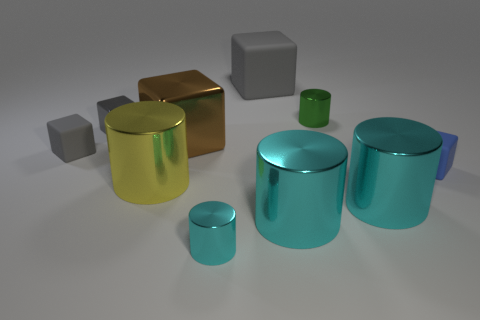Subtract all gray blocks. How many were subtracted if there are1gray blocks left? 2 Subtract all gray cubes. How many cyan cylinders are left? 3 Subtract all small blue cubes. How many cubes are left? 4 Subtract all brown cubes. How many cubes are left? 4 Subtract all red cubes. Subtract all yellow cylinders. How many cubes are left? 5 Subtract all large cylinders. Subtract all green cylinders. How many objects are left? 6 Add 9 small cyan metallic things. How many small cyan metallic things are left? 10 Add 7 matte cubes. How many matte cubes exist? 10 Subtract 0 purple spheres. How many objects are left? 10 